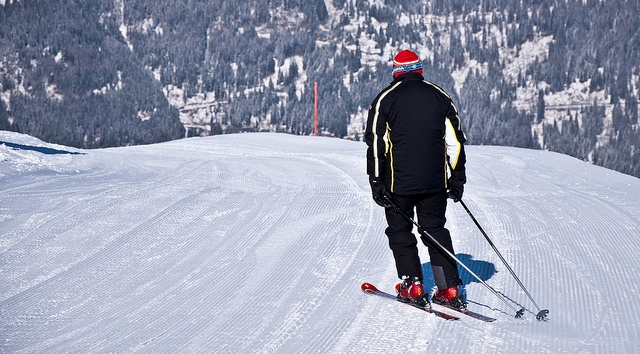Describe the objects in this image and their specific colors. I can see people in darkgray, black, white, gray, and maroon tones and skis in darkgray, gray, and maroon tones in this image. 